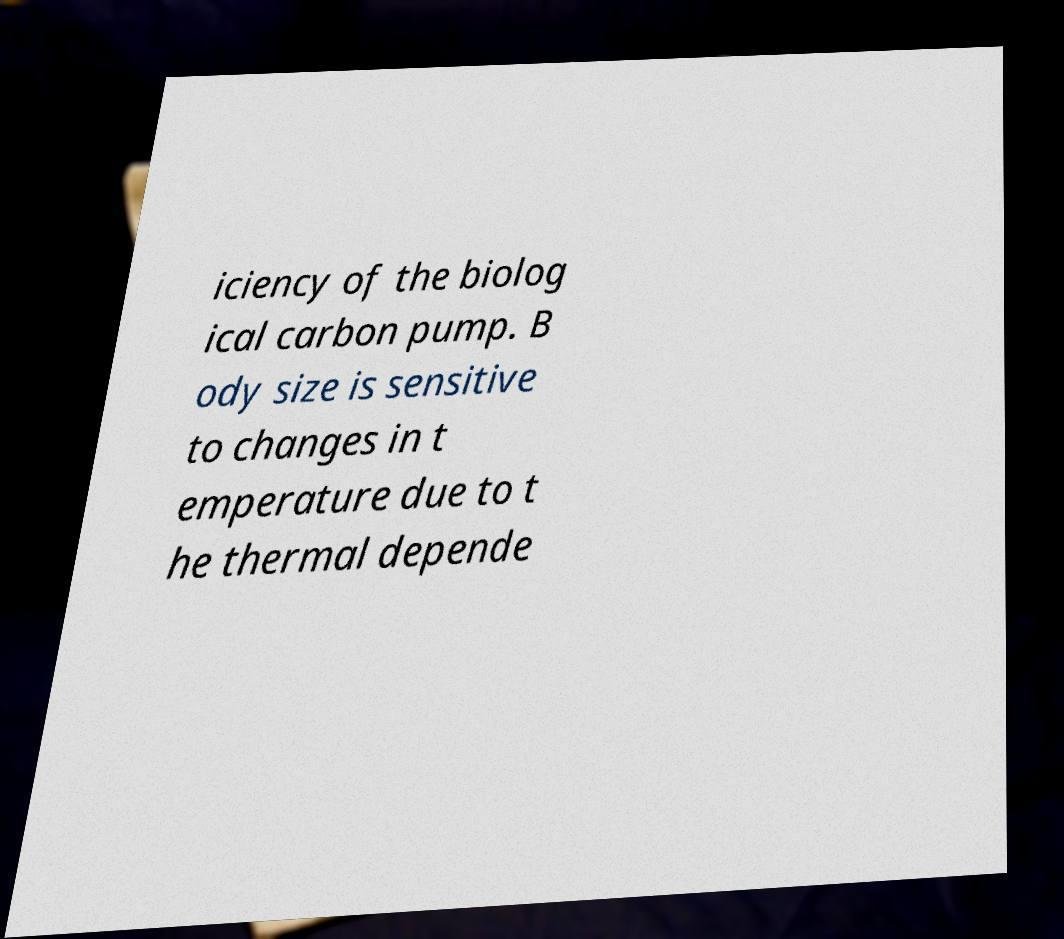Can you read and provide the text displayed in the image?This photo seems to have some interesting text. Can you extract and type it out for me? iciency of the biolog ical carbon pump. B ody size is sensitive to changes in t emperature due to t he thermal depende 